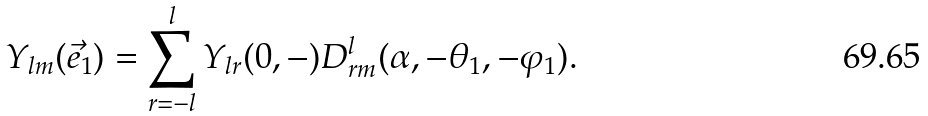Convert formula to latex. <formula><loc_0><loc_0><loc_500><loc_500>Y _ { l m } ( \vec { e } _ { 1 } ) = \sum _ { r = - l } ^ { l } Y _ { l r } ( 0 , - ) D _ { r m } ^ { l } ( \alpha , - \theta _ { 1 } , - \varphi _ { 1 } ) .</formula> 